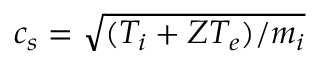<formula> <loc_0><loc_0><loc_500><loc_500>c _ { s } = \sqrt { ( T _ { i } + Z T _ { e } ) / m _ { i } }</formula> 